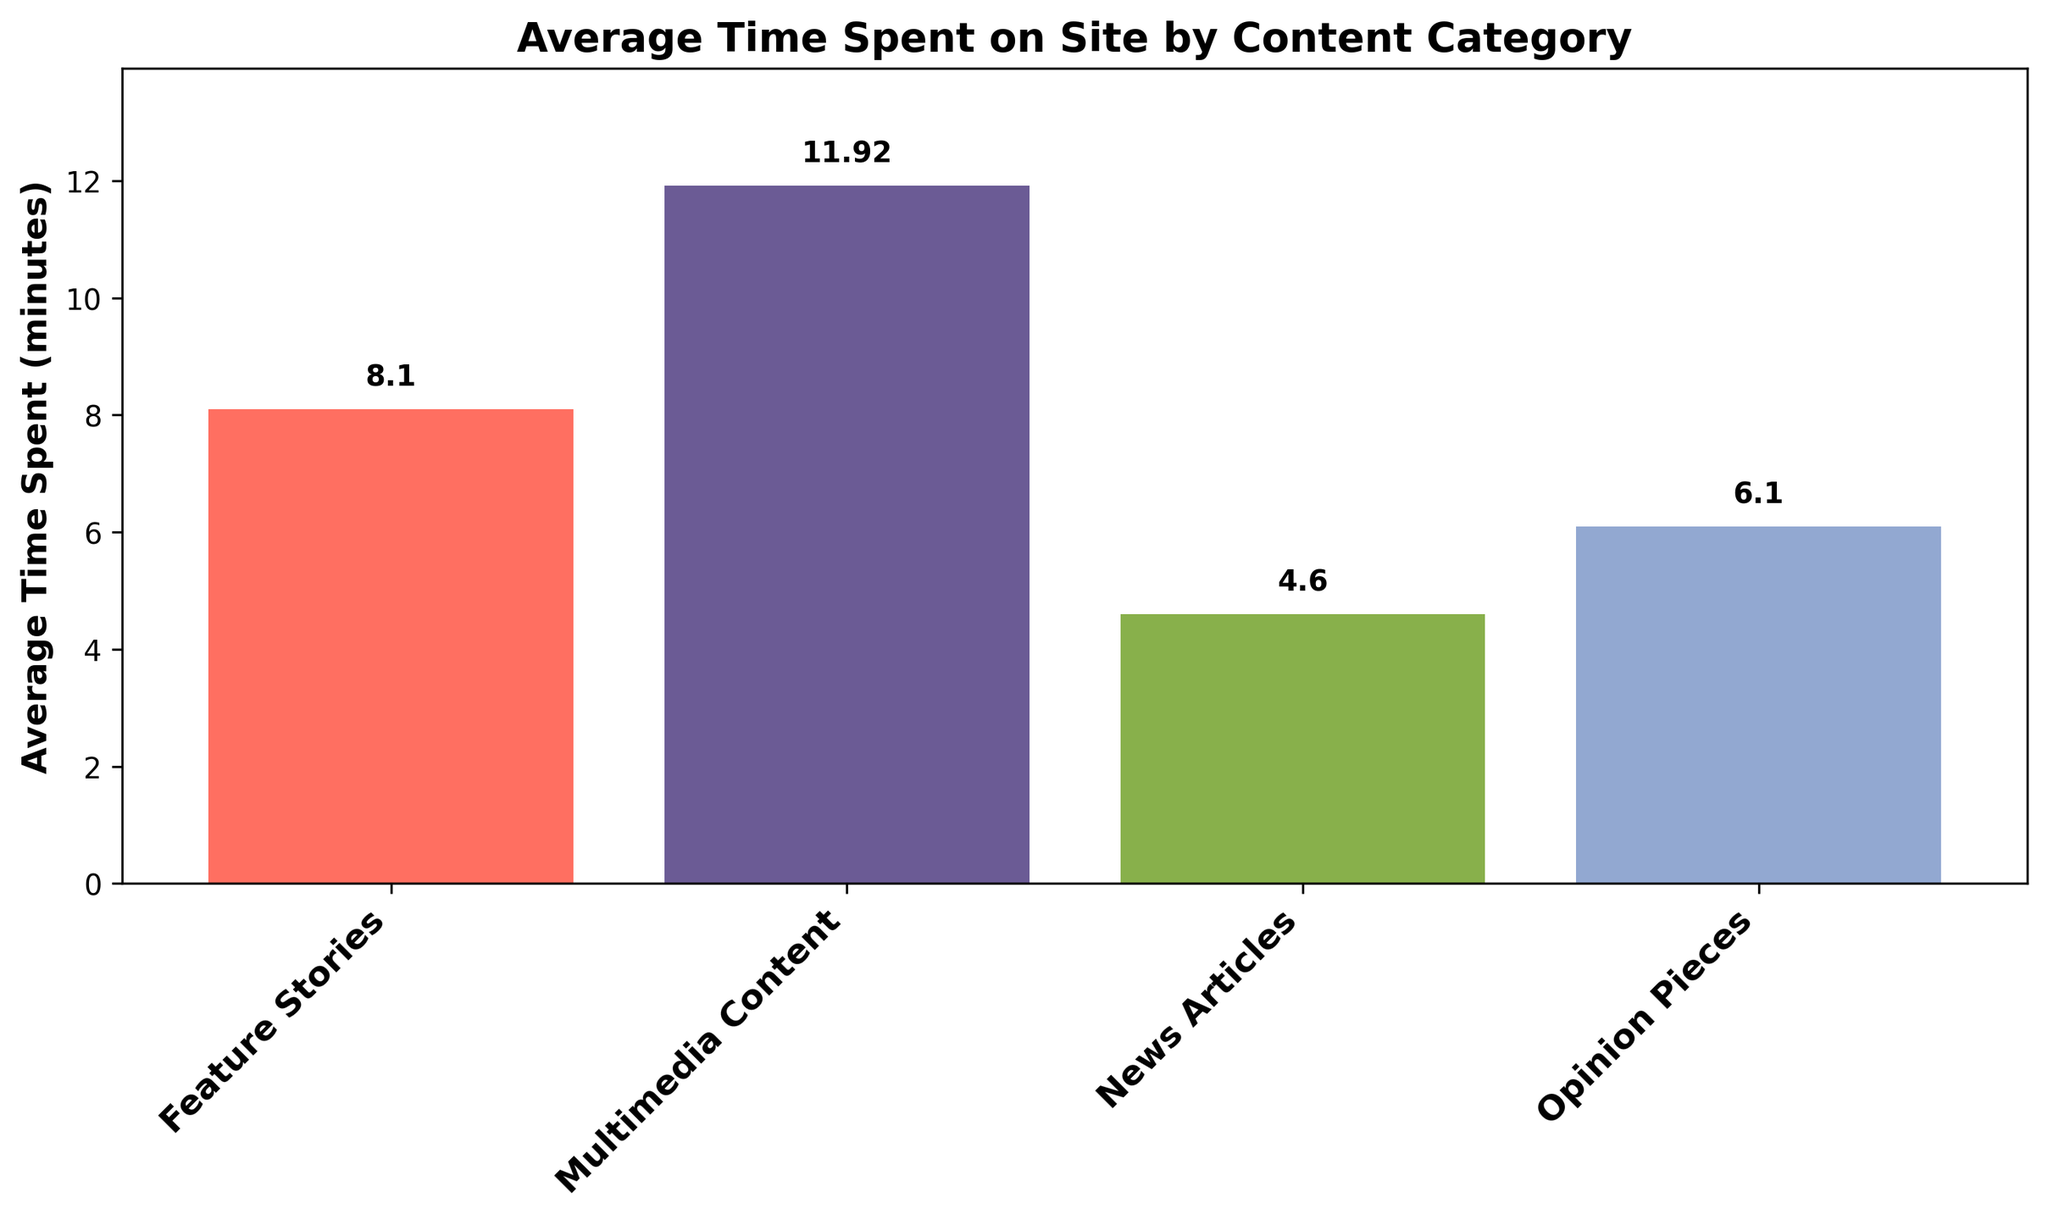Which content category had the highest average time spent on site? From the bar chart, the tallest bar represents the category with the highest average time spent, which is 'Multimedia Content'.
Answer: Multimedia Content What's the difference in average time spent on site between 'Feature Stories' and 'News Articles'? Look at the heights of the bars for 'Feature Stories' and 'News Articles'. The difference is 8.1 minutes (Feature Stories) - 4.6 minutes (News Articles) = 3.5 minutes.
Answer: 3.5 minutes Which content category shows the second highest average time spent on site? The second tallest bar represents the second highest category, which is 'Feature Stories'.
Answer: Feature Stories How much more time do users spend on 'Opinion Pieces' than on 'News Articles' on average? The average time for 'Opinion Pieces' is shown by the bar height (6.1 minutes) and for 'News Articles' (4.6 minutes). The difference is 6.1 - 4.6 = 1.5 minutes.
Answer: 1.5 minutes What is the average time spent on site for 'Feature Stories' based on the chart? Observe the bar corresponding to 'Feature Stories'. The label or height gives an average time of 8.1 minutes.
Answer: 8.1 minutes If you sum the average times spent on site for 'News Articles' and 'Multimedia Content', what is the result? The chart shows the average for 'News Articles' is 4.6 minutes and for 'Multimedia Content' is 12.0 minutes. Adding these together: 4.6 + 12.0 = 16.6 minutes.
Answer: 16.6 minutes Compare the average time spent on site for 'Opinion Pieces' and 'Feature Stories'. Is the average time spent on 'Feature Stories' greater or less than twice the average time spent on 'Opinion Pieces'? The bar for 'Opinion Pieces' shows an average time of 6.1 minutes. Twice this would be 6.1 * 2 = 12.2 minutes. The bar for 'Feature Stories' shows an average of 8.1 minutes, which is less than 12.2 minutes.
Answer: Less What inference can you draw about user engagement with 'Multimedia Content' compared to the other categories? 'Multimedia Content' has the tallest bar, indicating the highest average time spent, suggesting users are more engaged with multimedia content compared to other categories.
Answer: Higher engagement with multimedia If the average time spent on site across all categories increased by 10%, what would be the new average for 'Opinion Pieces’? The original average for 'Opinion Pieces' is 6.1 minutes. Increasing this by 10% means multiplying by 1.10: 6.1 * 1.10 = 6.71 minutes.
Answer: 6.71 minutes 